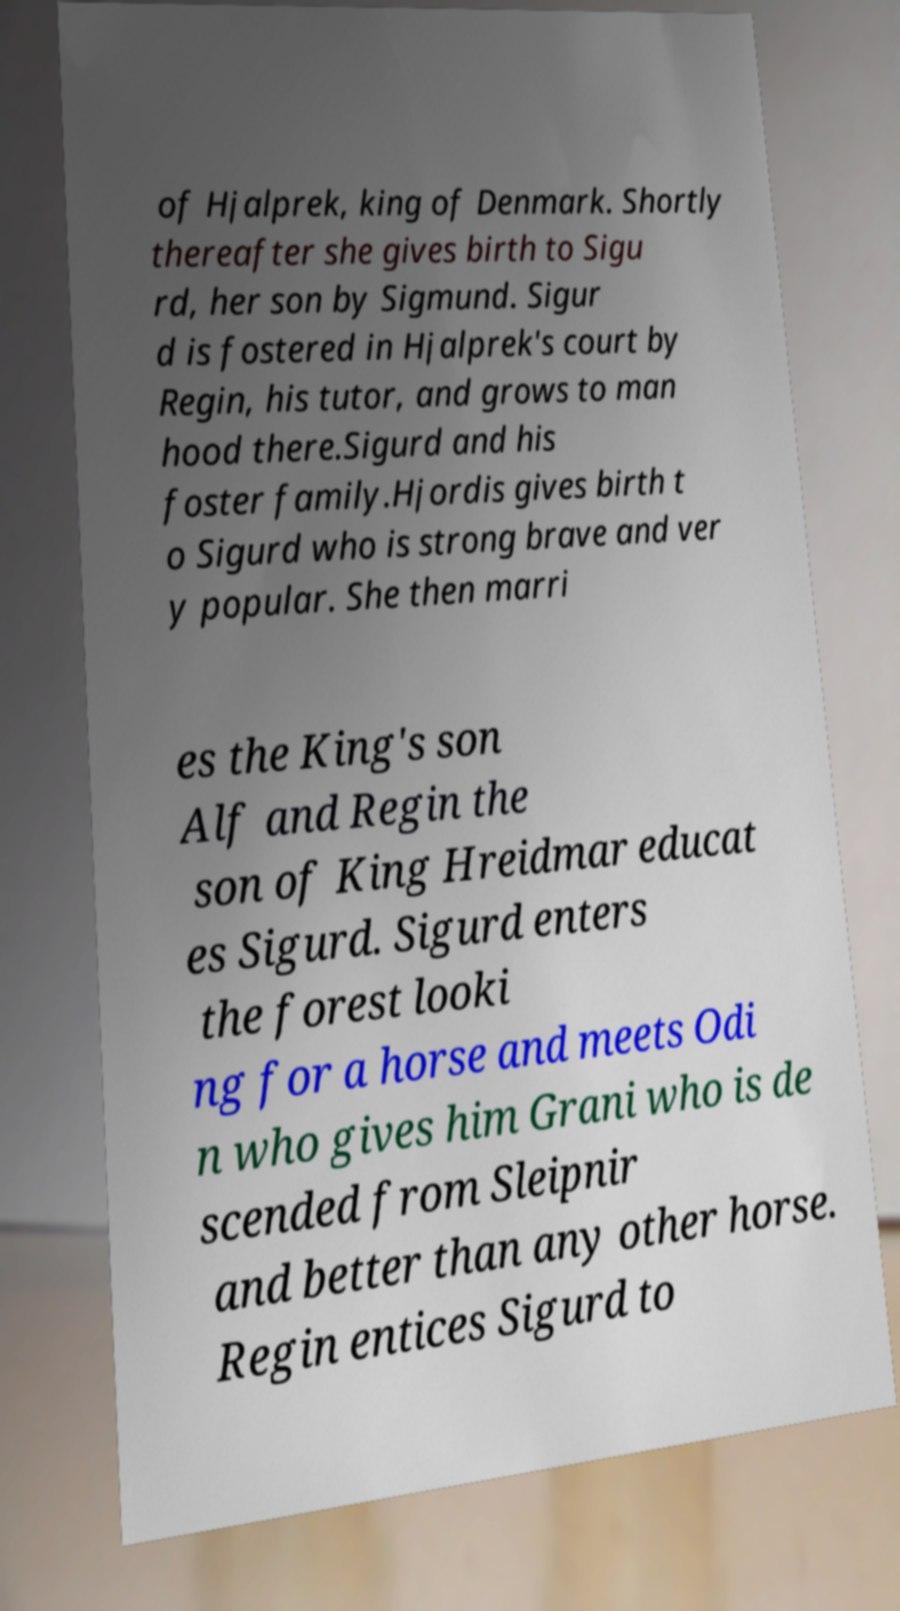Can you read and provide the text displayed in the image?This photo seems to have some interesting text. Can you extract and type it out for me? of Hjalprek, king of Denmark. Shortly thereafter she gives birth to Sigu rd, her son by Sigmund. Sigur d is fostered in Hjalprek's court by Regin, his tutor, and grows to man hood there.Sigurd and his foster family.Hjordis gives birth t o Sigurd who is strong brave and ver y popular. She then marri es the King's son Alf and Regin the son of King Hreidmar educat es Sigurd. Sigurd enters the forest looki ng for a horse and meets Odi n who gives him Grani who is de scended from Sleipnir and better than any other horse. Regin entices Sigurd to 